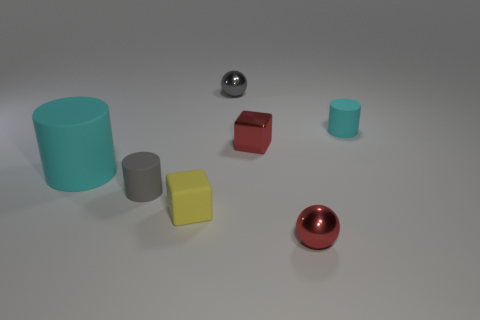Add 3 small shiny cubes. How many objects exist? 10 Subtract all cylinders. How many objects are left? 4 Subtract all small cyan objects. Subtract all metal things. How many objects are left? 3 Add 4 tiny cyan cylinders. How many tiny cyan cylinders are left? 5 Add 3 small gray metal things. How many small gray metal things exist? 4 Subtract 0 red cylinders. How many objects are left? 7 